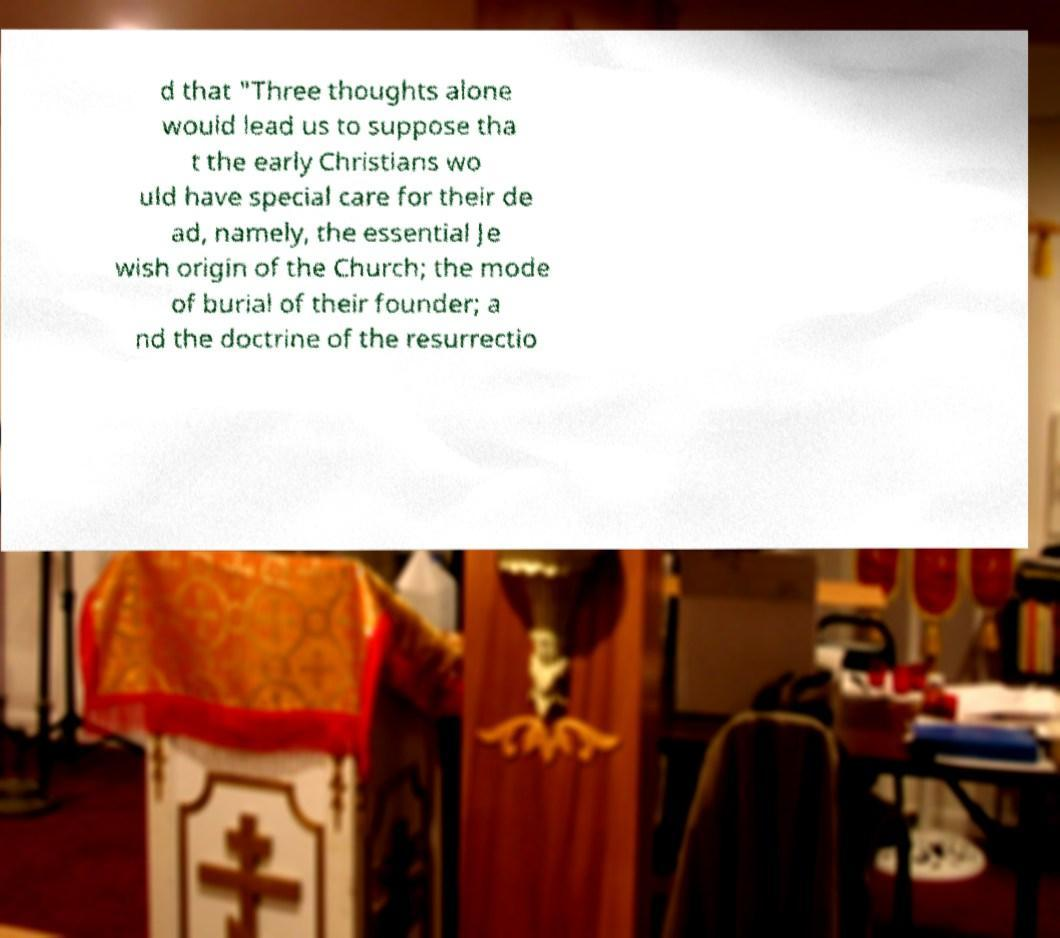Can you read and provide the text displayed in the image?This photo seems to have some interesting text. Can you extract and type it out for me? d that "Three thoughts alone would lead us to suppose tha t the early Christians wo uld have special care for their de ad, namely, the essential Je wish origin of the Church; the mode of burial of their founder; a nd the doctrine of the resurrectio 